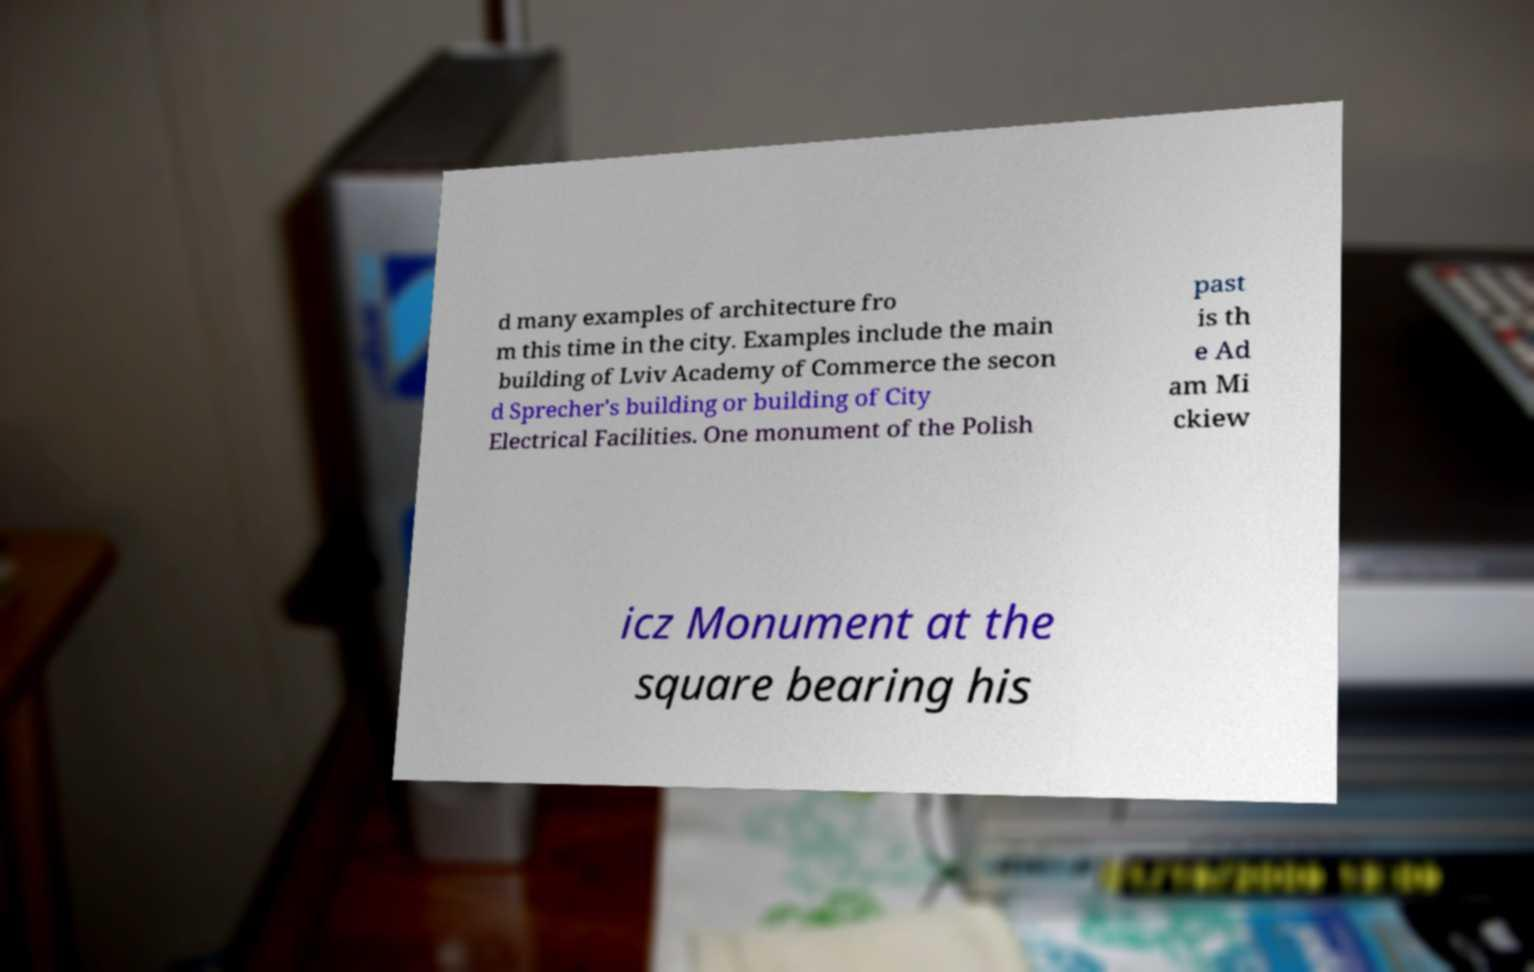Could you assist in decoding the text presented in this image and type it out clearly? d many examples of architecture fro m this time in the city. Examples include the main building of Lviv Academy of Commerce the secon d Sprecher's building or building of City Electrical Facilities. One monument of the Polish past is th e Ad am Mi ckiew icz Monument at the square bearing his 